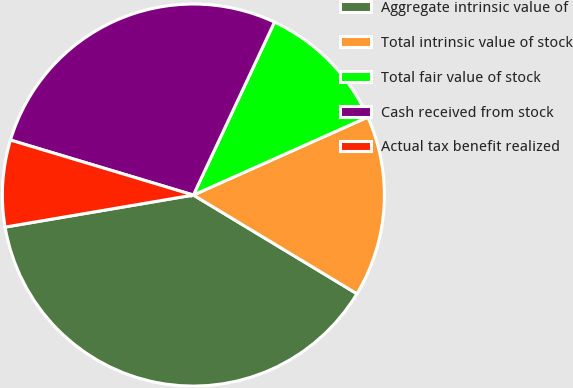Convert chart to OTSL. <chart><loc_0><loc_0><loc_500><loc_500><pie_chart><fcel>Aggregate intrinsic value of<fcel>Total intrinsic value of stock<fcel>Total fair value of stock<fcel>Cash received from stock<fcel>Actual tax benefit realized<nl><fcel>38.67%<fcel>15.33%<fcel>11.33%<fcel>27.33%<fcel>7.33%<nl></chart> 